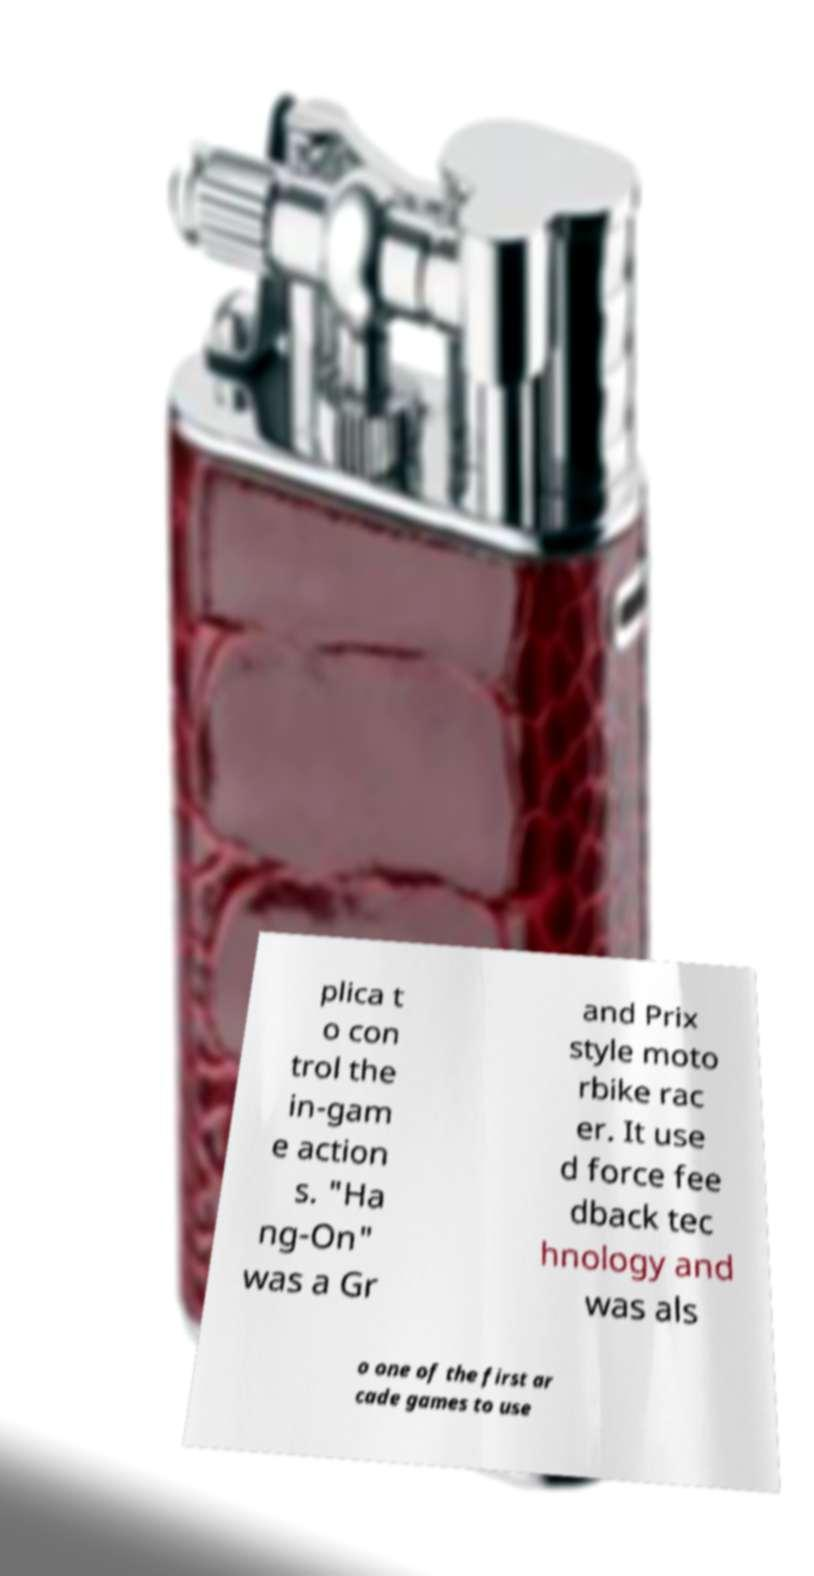Could you assist in decoding the text presented in this image and type it out clearly? plica t o con trol the in-gam e action s. "Ha ng-On" was a Gr and Prix style moto rbike rac er. It use d force fee dback tec hnology and was als o one of the first ar cade games to use 